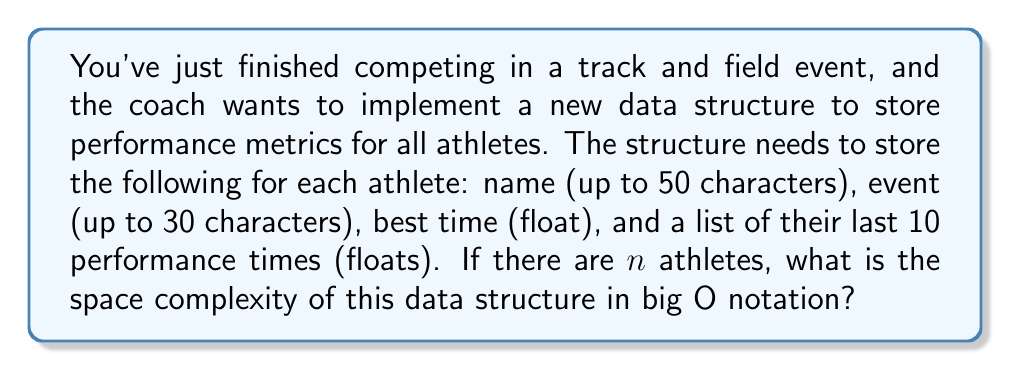Help me with this question. Let's break this down step-by-step:

1) For each athlete, we need to store:
   - Name: 50 characters = 50 bytes (assuming 1 byte per character)
   - Event: 30 characters = 30 bytes
   - Best time: 1 float = 4 bytes (assuming 32-bit float)
   - Last 10 performance times: 10 floats = 10 * 4 = 40 bytes

2) Total storage per athlete:
   $50 + 30 + 4 + 40 = 124$ bytes

3) For $n$ athletes, the total storage would be:
   $124n$ bytes

4) In big O notation, we drop constants. So the space complexity is $O(n)$.

The space complexity is linear with respect to the number of athletes, as the amount of data stored for each athlete is constant (it doesn't change with $n$).

Note: Even if we considered that strings might be stored as pointers (which would be 8 bytes on a 64-bit system) plus the actual string data, it would still result in a linear space complexity, just with different constants.
Answer: $O(n)$ 